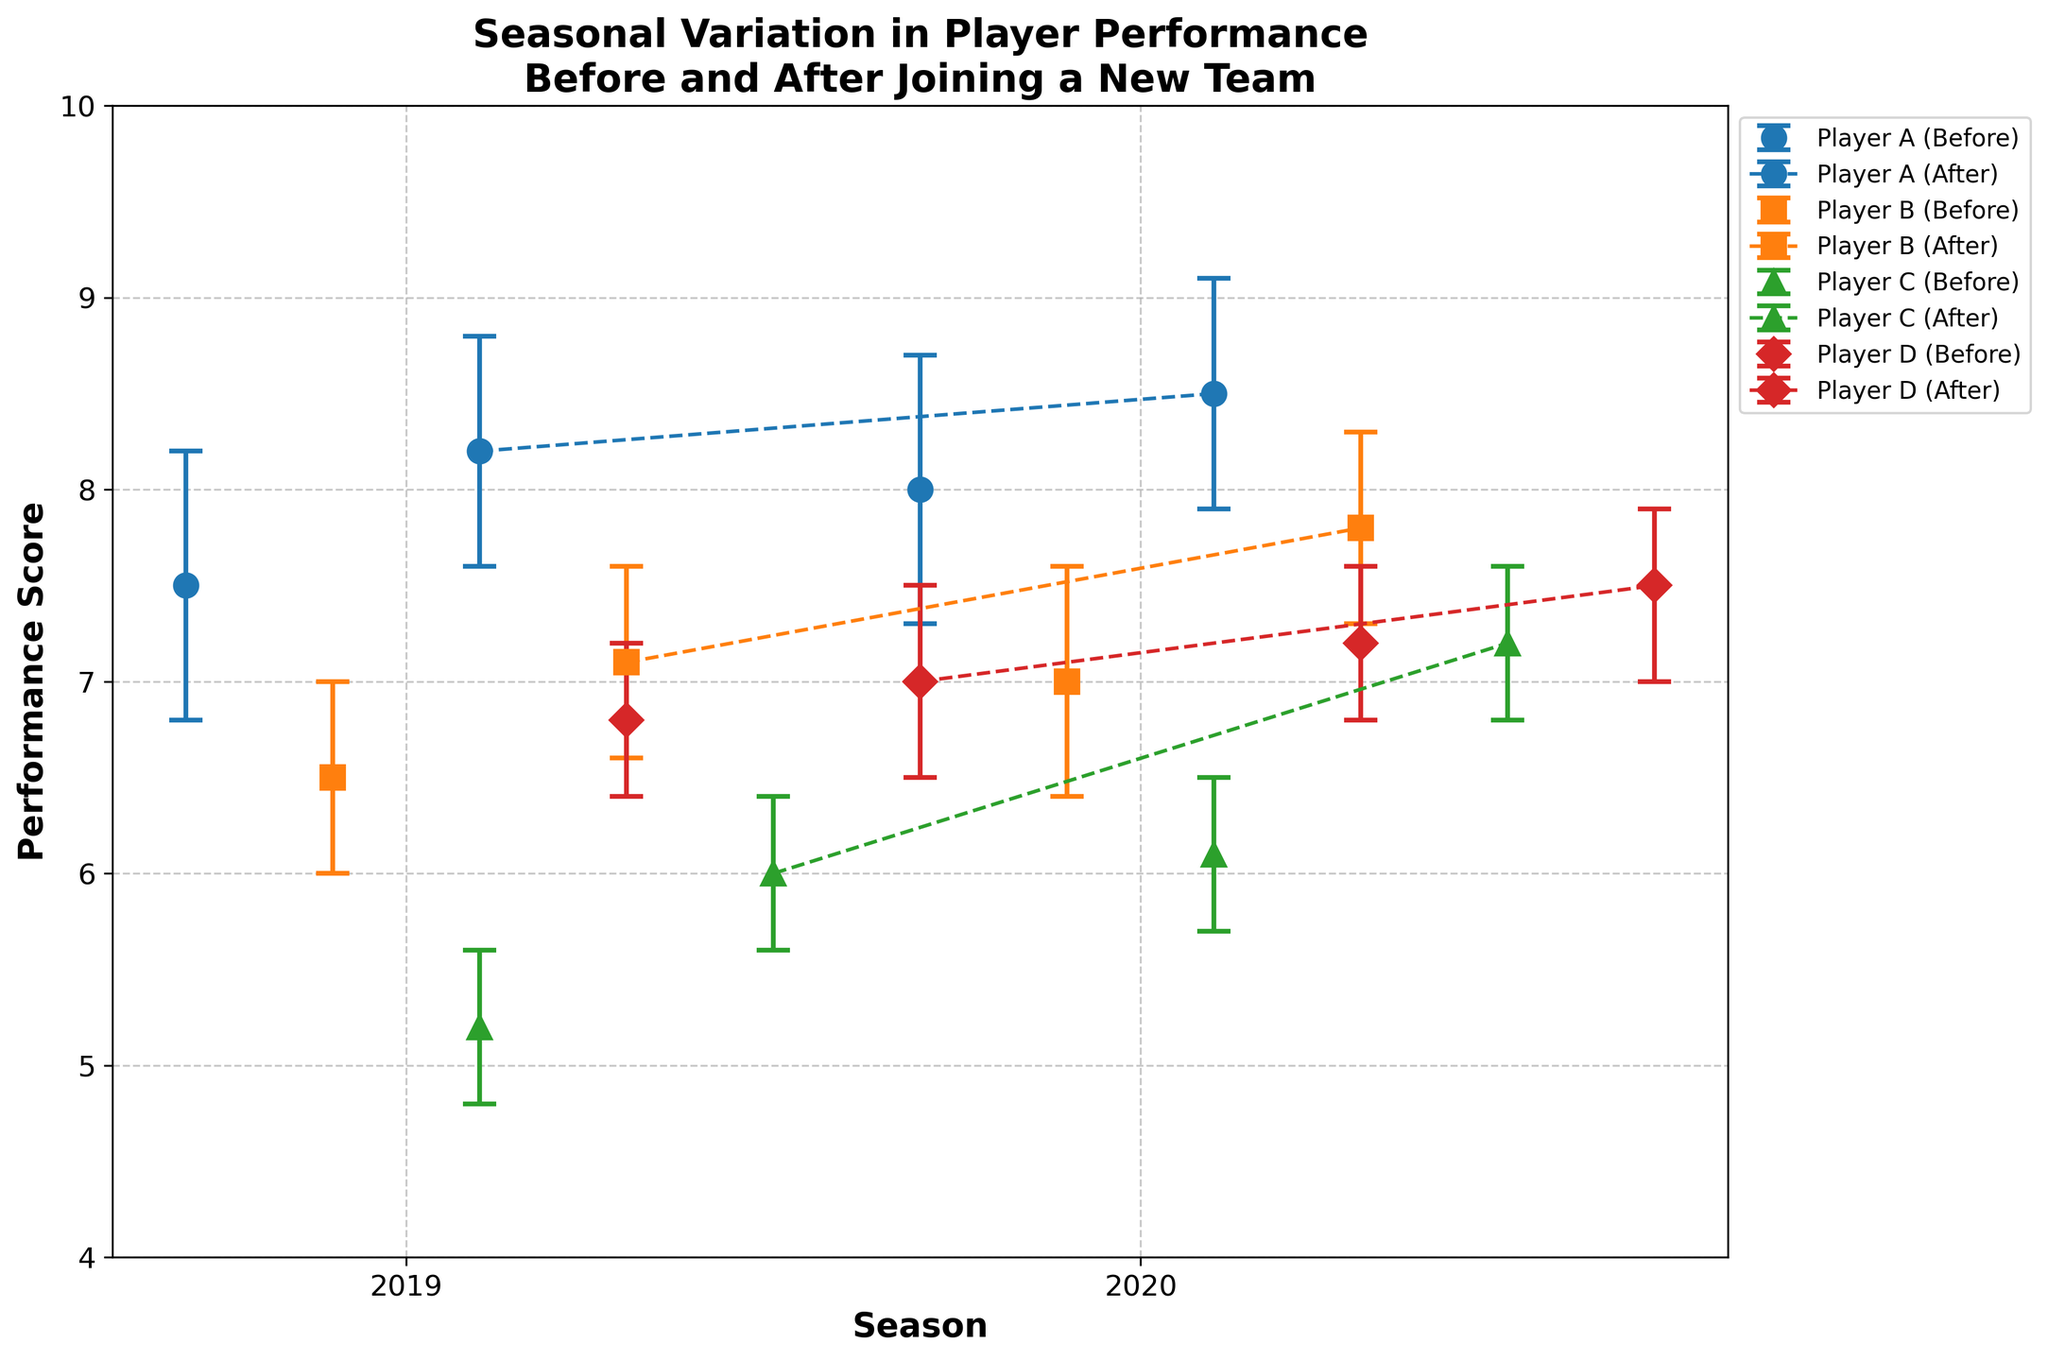What's the title of the figure? The title of the figure is typically found at the top and usually summarizes what the plot is depicting. In this case, it should describe the seasonal variation in player performance before and after joining new teams, including confidence intervals.
Answer: Seasonal Variation in Player Performance Before and After Joining a New Team What is the performance score range shown on the y-axis? The y-axis typically displays the performance scores. Observing the y-axis labels gives the minimum and maximum values. In this plot, it ranges from 4 to 10.
Answer: 4 to 10 How many seasons are depicted in the plot? The x-axis labels usually indicate different categories or time periods. By counting the number of tick marks on the x-axis, we can determine the number of seasons. Here, there are two: 2019 and 2020.
Answer: 2 For Player A, in which season was the performance after joining the new team higher than before? To answer this, compare the performance scores of Player A before and after joining the new team for each season. In 2020, Player A's performance after (8.5) is higher than before (8.0).
Answer: 2020 Which player showed the largest improvement in performance after joining a new team in 2020? Calculate the difference between performance after and before for each player in 2020, and find the maximum. Player C improved from 6.1 to 7.2, which is an increase of 1.1, the largest among all.
Answer: Player C Which player had the smallest increase in performance after joining a new team in 2019? Calculate the difference between performance after and before for each player in 2019. The smallest increase is for Player D, from 6.8 to 7.0, a difference of 0.2.
Answer: Player D What was Player B’s performance before and after joining a new team in 2019, including the confidence intervals? Refer to the plot markers and error bars for Player B for the 2019 season, noting the performance values and confidence interval ranges. Performance before: 6.5 [6.0, 7.0]. Performance after: 7.1 [6.6, 7.6].
Answer: Performance before: 6.5 [6.0, 7.0], Performance after: 7.1 [6.6, 7.6] Which player had the highest performance score after joining a new team in 2020? Examine all the performance scores after joining a new team in 2020, and identify the highest one. Player C had the highest after (7.2).
Answer: Player C Which player's performance shows the most consistent improvement across both seasons? Determine the performance improvement for each player across both seasons and see which player has a positive difference in each. Player C improved in both 2019 (from 5.2 to 6.0) and 2020 (from 6.1 to 7.2).
Answer: Player C What general trend can be observed regarding player performance before and after joining new teams? Analyze the overall differences in performance scores of all players before and after joining new teams across both seasons. Generally, players' performances appear to improve after joining new teams.
Answer: Improvement 